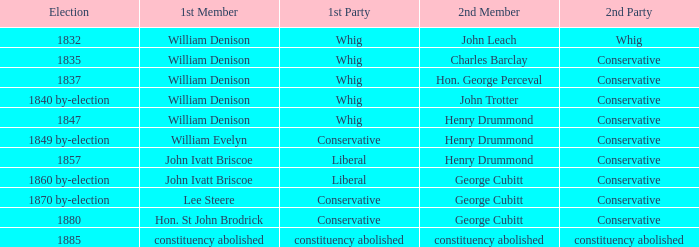Which party with an 1835 election has 1st member William Denison? Conservative. 